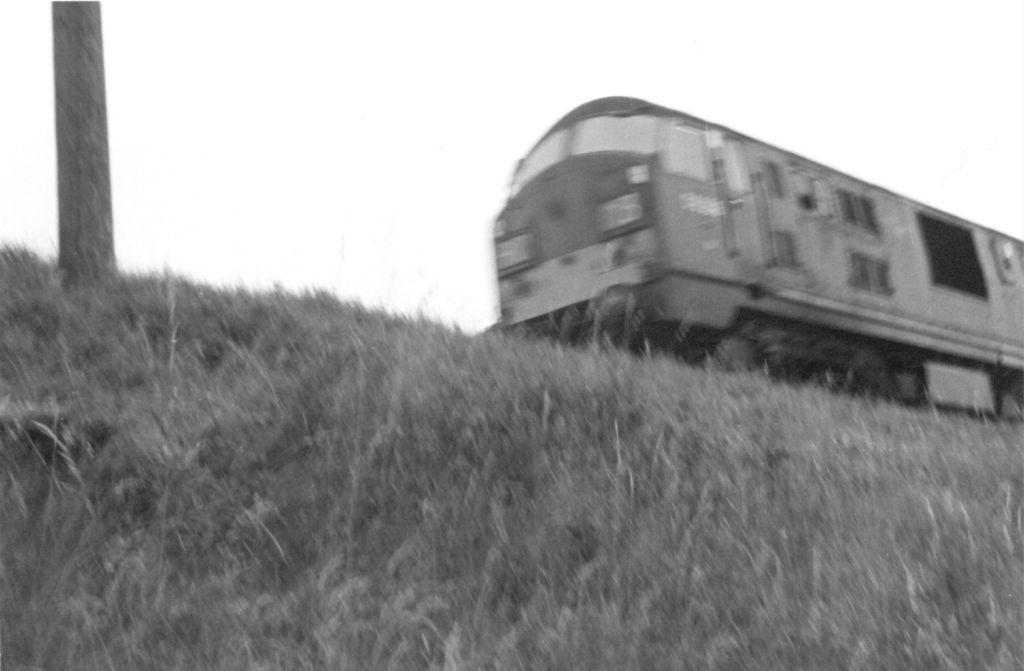What type of surface is visible in the image? There is a grass surface in the image. What type of vegetation is present on the grass surface? Grass plants are present on the grass surface. What structure can be seen in the image? There is a pole in the image. What mode of transportation is visible in the image? A train is visible beside the pole. Where is the pig swimming in the river in the image? There is no pig or river present in the image. 